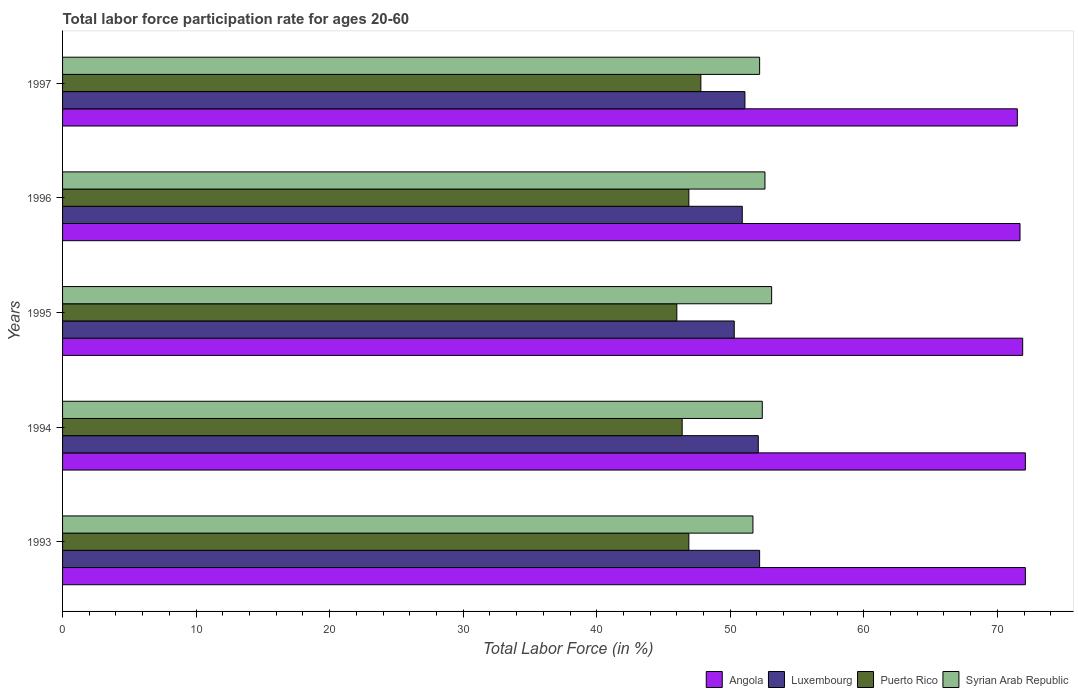How many different coloured bars are there?
Your answer should be very brief. 4. Are the number of bars per tick equal to the number of legend labels?
Provide a succinct answer. Yes. Are the number of bars on each tick of the Y-axis equal?
Offer a very short reply. Yes. How many bars are there on the 1st tick from the top?
Offer a terse response. 4. In how many cases, is the number of bars for a given year not equal to the number of legend labels?
Ensure brevity in your answer.  0. What is the labor force participation rate in Syrian Arab Republic in 1993?
Provide a short and direct response. 51.7. Across all years, what is the maximum labor force participation rate in Syrian Arab Republic?
Your answer should be very brief. 53.1. Across all years, what is the minimum labor force participation rate in Luxembourg?
Offer a very short reply. 50.3. In which year was the labor force participation rate in Angola maximum?
Provide a short and direct response. 1993. What is the total labor force participation rate in Syrian Arab Republic in the graph?
Offer a terse response. 262. What is the difference between the labor force participation rate in Puerto Rico in 1993 and that in 1994?
Offer a terse response. 0.5. What is the difference between the labor force participation rate in Luxembourg in 1993 and the labor force participation rate in Angola in 1995?
Offer a very short reply. -19.7. What is the average labor force participation rate in Puerto Rico per year?
Offer a terse response. 46.8. In the year 1996, what is the difference between the labor force participation rate in Angola and labor force participation rate in Syrian Arab Republic?
Make the answer very short. 19.1. What is the ratio of the labor force participation rate in Syrian Arab Republic in 1994 to that in 1996?
Offer a terse response. 1. What is the difference between the highest and the second highest labor force participation rate in Syrian Arab Republic?
Give a very brief answer. 0.5. What is the difference between the highest and the lowest labor force participation rate in Puerto Rico?
Provide a succinct answer. 1.8. What does the 2nd bar from the top in 1996 represents?
Ensure brevity in your answer.  Puerto Rico. What does the 3rd bar from the bottom in 1994 represents?
Give a very brief answer. Puerto Rico. How many bars are there?
Your response must be concise. 20. Are all the bars in the graph horizontal?
Give a very brief answer. Yes. Are the values on the major ticks of X-axis written in scientific E-notation?
Provide a short and direct response. No. How many legend labels are there?
Ensure brevity in your answer.  4. How are the legend labels stacked?
Ensure brevity in your answer.  Horizontal. What is the title of the graph?
Your response must be concise. Total labor force participation rate for ages 20-60. What is the Total Labor Force (in %) of Angola in 1993?
Provide a short and direct response. 72.1. What is the Total Labor Force (in %) of Luxembourg in 1993?
Your answer should be compact. 52.2. What is the Total Labor Force (in %) of Puerto Rico in 1993?
Offer a terse response. 46.9. What is the Total Labor Force (in %) of Syrian Arab Republic in 1993?
Ensure brevity in your answer.  51.7. What is the Total Labor Force (in %) of Angola in 1994?
Provide a succinct answer. 72.1. What is the Total Labor Force (in %) in Luxembourg in 1994?
Your answer should be compact. 52.1. What is the Total Labor Force (in %) of Puerto Rico in 1994?
Provide a short and direct response. 46.4. What is the Total Labor Force (in %) in Syrian Arab Republic in 1994?
Provide a succinct answer. 52.4. What is the Total Labor Force (in %) of Angola in 1995?
Provide a short and direct response. 71.9. What is the Total Labor Force (in %) in Luxembourg in 1995?
Give a very brief answer. 50.3. What is the Total Labor Force (in %) of Syrian Arab Republic in 1995?
Your response must be concise. 53.1. What is the Total Labor Force (in %) of Angola in 1996?
Give a very brief answer. 71.7. What is the Total Labor Force (in %) of Luxembourg in 1996?
Make the answer very short. 50.9. What is the Total Labor Force (in %) in Puerto Rico in 1996?
Offer a terse response. 46.9. What is the Total Labor Force (in %) of Syrian Arab Republic in 1996?
Your answer should be compact. 52.6. What is the Total Labor Force (in %) of Angola in 1997?
Offer a terse response. 71.5. What is the Total Labor Force (in %) in Luxembourg in 1997?
Offer a terse response. 51.1. What is the Total Labor Force (in %) in Puerto Rico in 1997?
Give a very brief answer. 47.8. What is the Total Labor Force (in %) in Syrian Arab Republic in 1997?
Keep it short and to the point. 52.2. Across all years, what is the maximum Total Labor Force (in %) in Angola?
Make the answer very short. 72.1. Across all years, what is the maximum Total Labor Force (in %) of Luxembourg?
Provide a short and direct response. 52.2. Across all years, what is the maximum Total Labor Force (in %) of Puerto Rico?
Give a very brief answer. 47.8. Across all years, what is the maximum Total Labor Force (in %) of Syrian Arab Republic?
Ensure brevity in your answer.  53.1. Across all years, what is the minimum Total Labor Force (in %) of Angola?
Ensure brevity in your answer.  71.5. Across all years, what is the minimum Total Labor Force (in %) of Luxembourg?
Provide a short and direct response. 50.3. Across all years, what is the minimum Total Labor Force (in %) of Puerto Rico?
Make the answer very short. 46. Across all years, what is the minimum Total Labor Force (in %) in Syrian Arab Republic?
Keep it short and to the point. 51.7. What is the total Total Labor Force (in %) in Angola in the graph?
Give a very brief answer. 359.3. What is the total Total Labor Force (in %) in Luxembourg in the graph?
Provide a short and direct response. 256.6. What is the total Total Labor Force (in %) of Puerto Rico in the graph?
Offer a terse response. 234. What is the total Total Labor Force (in %) in Syrian Arab Republic in the graph?
Keep it short and to the point. 262. What is the difference between the Total Labor Force (in %) in Angola in 1993 and that in 1994?
Make the answer very short. 0. What is the difference between the Total Labor Force (in %) in Luxembourg in 1993 and that in 1994?
Your response must be concise. 0.1. What is the difference between the Total Labor Force (in %) in Puerto Rico in 1993 and that in 1994?
Keep it short and to the point. 0.5. What is the difference between the Total Labor Force (in %) in Angola in 1993 and that in 1995?
Keep it short and to the point. 0.2. What is the difference between the Total Labor Force (in %) of Luxembourg in 1993 and that in 1995?
Your response must be concise. 1.9. What is the difference between the Total Labor Force (in %) of Syrian Arab Republic in 1993 and that in 1995?
Ensure brevity in your answer.  -1.4. What is the difference between the Total Labor Force (in %) of Angola in 1993 and that in 1997?
Provide a short and direct response. 0.6. What is the difference between the Total Labor Force (in %) of Syrian Arab Republic in 1993 and that in 1997?
Your response must be concise. -0.5. What is the difference between the Total Labor Force (in %) in Angola in 1994 and that in 1995?
Ensure brevity in your answer.  0.2. What is the difference between the Total Labor Force (in %) in Luxembourg in 1994 and that in 1995?
Provide a short and direct response. 1.8. What is the difference between the Total Labor Force (in %) in Puerto Rico in 1994 and that in 1995?
Offer a very short reply. 0.4. What is the difference between the Total Labor Force (in %) of Syrian Arab Republic in 1994 and that in 1995?
Offer a very short reply. -0.7. What is the difference between the Total Labor Force (in %) of Angola in 1994 and that in 1996?
Your answer should be very brief. 0.4. What is the difference between the Total Labor Force (in %) in Luxembourg in 1994 and that in 1996?
Make the answer very short. 1.2. What is the difference between the Total Labor Force (in %) in Syrian Arab Republic in 1994 and that in 1996?
Offer a very short reply. -0.2. What is the difference between the Total Labor Force (in %) in Syrian Arab Republic in 1994 and that in 1997?
Make the answer very short. 0.2. What is the difference between the Total Labor Force (in %) in Angola in 1995 and that in 1996?
Make the answer very short. 0.2. What is the difference between the Total Labor Force (in %) of Syrian Arab Republic in 1995 and that in 1996?
Your response must be concise. 0.5. What is the difference between the Total Labor Force (in %) in Luxembourg in 1995 and that in 1997?
Your answer should be very brief. -0.8. What is the difference between the Total Labor Force (in %) of Angola in 1996 and that in 1997?
Make the answer very short. 0.2. What is the difference between the Total Labor Force (in %) in Luxembourg in 1996 and that in 1997?
Make the answer very short. -0.2. What is the difference between the Total Labor Force (in %) of Puerto Rico in 1996 and that in 1997?
Your answer should be very brief. -0.9. What is the difference between the Total Labor Force (in %) of Syrian Arab Republic in 1996 and that in 1997?
Ensure brevity in your answer.  0.4. What is the difference between the Total Labor Force (in %) in Angola in 1993 and the Total Labor Force (in %) in Luxembourg in 1994?
Provide a succinct answer. 20. What is the difference between the Total Labor Force (in %) in Angola in 1993 and the Total Labor Force (in %) in Puerto Rico in 1994?
Provide a short and direct response. 25.7. What is the difference between the Total Labor Force (in %) in Angola in 1993 and the Total Labor Force (in %) in Syrian Arab Republic in 1994?
Your response must be concise. 19.7. What is the difference between the Total Labor Force (in %) of Luxembourg in 1993 and the Total Labor Force (in %) of Syrian Arab Republic in 1994?
Keep it short and to the point. -0.2. What is the difference between the Total Labor Force (in %) of Angola in 1993 and the Total Labor Force (in %) of Luxembourg in 1995?
Keep it short and to the point. 21.8. What is the difference between the Total Labor Force (in %) in Angola in 1993 and the Total Labor Force (in %) in Puerto Rico in 1995?
Offer a terse response. 26.1. What is the difference between the Total Labor Force (in %) of Luxembourg in 1993 and the Total Labor Force (in %) of Syrian Arab Republic in 1995?
Your answer should be compact. -0.9. What is the difference between the Total Labor Force (in %) in Angola in 1993 and the Total Labor Force (in %) in Luxembourg in 1996?
Your response must be concise. 21.2. What is the difference between the Total Labor Force (in %) of Angola in 1993 and the Total Labor Force (in %) of Puerto Rico in 1996?
Make the answer very short. 25.2. What is the difference between the Total Labor Force (in %) of Puerto Rico in 1993 and the Total Labor Force (in %) of Syrian Arab Republic in 1996?
Offer a terse response. -5.7. What is the difference between the Total Labor Force (in %) in Angola in 1993 and the Total Labor Force (in %) in Luxembourg in 1997?
Offer a very short reply. 21. What is the difference between the Total Labor Force (in %) of Angola in 1993 and the Total Labor Force (in %) of Puerto Rico in 1997?
Ensure brevity in your answer.  24.3. What is the difference between the Total Labor Force (in %) in Angola in 1994 and the Total Labor Force (in %) in Luxembourg in 1995?
Provide a short and direct response. 21.8. What is the difference between the Total Labor Force (in %) in Angola in 1994 and the Total Labor Force (in %) in Puerto Rico in 1995?
Your answer should be compact. 26.1. What is the difference between the Total Labor Force (in %) of Luxembourg in 1994 and the Total Labor Force (in %) of Syrian Arab Republic in 1995?
Your answer should be very brief. -1. What is the difference between the Total Labor Force (in %) of Angola in 1994 and the Total Labor Force (in %) of Luxembourg in 1996?
Give a very brief answer. 21.2. What is the difference between the Total Labor Force (in %) of Angola in 1994 and the Total Labor Force (in %) of Puerto Rico in 1996?
Provide a succinct answer. 25.2. What is the difference between the Total Labor Force (in %) in Angola in 1994 and the Total Labor Force (in %) in Syrian Arab Republic in 1996?
Your response must be concise. 19.5. What is the difference between the Total Labor Force (in %) in Luxembourg in 1994 and the Total Labor Force (in %) in Puerto Rico in 1996?
Provide a short and direct response. 5.2. What is the difference between the Total Labor Force (in %) of Luxembourg in 1994 and the Total Labor Force (in %) of Syrian Arab Republic in 1996?
Offer a very short reply. -0.5. What is the difference between the Total Labor Force (in %) in Puerto Rico in 1994 and the Total Labor Force (in %) in Syrian Arab Republic in 1996?
Your answer should be compact. -6.2. What is the difference between the Total Labor Force (in %) in Angola in 1994 and the Total Labor Force (in %) in Puerto Rico in 1997?
Keep it short and to the point. 24.3. What is the difference between the Total Labor Force (in %) of Luxembourg in 1994 and the Total Labor Force (in %) of Puerto Rico in 1997?
Your answer should be very brief. 4.3. What is the difference between the Total Labor Force (in %) in Puerto Rico in 1994 and the Total Labor Force (in %) in Syrian Arab Republic in 1997?
Ensure brevity in your answer.  -5.8. What is the difference between the Total Labor Force (in %) of Angola in 1995 and the Total Labor Force (in %) of Syrian Arab Republic in 1996?
Keep it short and to the point. 19.3. What is the difference between the Total Labor Force (in %) of Luxembourg in 1995 and the Total Labor Force (in %) of Syrian Arab Republic in 1996?
Ensure brevity in your answer.  -2.3. What is the difference between the Total Labor Force (in %) of Puerto Rico in 1995 and the Total Labor Force (in %) of Syrian Arab Republic in 1996?
Your response must be concise. -6.6. What is the difference between the Total Labor Force (in %) of Angola in 1995 and the Total Labor Force (in %) of Luxembourg in 1997?
Provide a succinct answer. 20.8. What is the difference between the Total Labor Force (in %) in Angola in 1995 and the Total Labor Force (in %) in Puerto Rico in 1997?
Your answer should be compact. 24.1. What is the difference between the Total Labor Force (in %) in Luxembourg in 1995 and the Total Labor Force (in %) in Puerto Rico in 1997?
Give a very brief answer. 2.5. What is the difference between the Total Labor Force (in %) of Angola in 1996 and the Total Labor Force (in %) of Luxembourg in 1997?
Provide a succinct answer. 20.6. What is the difference between the Total Labor Force (in %) of Angola in 1996 and the Total Labor Force (in %) of Puerto Rico in 1997?
Your answer should be very brief. 23.9. What is the difference between the Total Labor Force (in %) in Angola in 1996 and the Total Labor Force (in %) in Syrian Arab Republic in 1997?
Your answer should be compact. 19.5. What is the difference between the Total Labor Force (in %) of Luxembourg in 1996 and the Total Labor Force (in %) of Puerto Rico in 1997?
Ensure brevity in your answer.  3.1. What is the difference between the Total Labor Force (in %) of Puerto Rico in 1996 and the Total Labor Force (in %) of Syrian Arab Republic in 1997?
Your answer should be very brief. -5.3. What is the average Total Labor Force (in %) in Angola per year?
Keep it short and to the point. 71.86. What is the average Total Labor Force (in %) in Luxembourg per year?
Provide a short and direct response. 51.32. What is the average Total Labor Force (in %) of Puerto Rico per year?
Ensure brevity in your answer.  46.8. What is the average Total Labor Force (in %) in Syrian Arab Republic per year?
Provide a short and direct response. 52.4. In the year 1993, what is the difference between the Total Labor Force (in %) of Angola and Total Labor Force (in %) of Puerto Rico?
Ensure brevity in your answer.  25.2. In the year 1993, what is the difference between the Total Labor Force (in %) of Angola and Total Labor Force (in %) of Syrian Arab Republic?
Provide a succinct answer. 20.4. In the year 1994, what is the difference between the Total Labor Force (in %) in Angola and Total Labor Force (in %) in Luxembourg?
Make the answer very short. 20. In the year 1994, what is the difference between the Total Labor Force (in %) of Angola and Total Labor Force (in %) of Puerto Rico?
Keep it short and to the point. 25.7. In the year 1994, what is the difference between the Total Labor Force (in %) of Angola and Total Labor Force (in %) of Syrian Arab Republic?
Make the answer very short. 19.7. In the year 1994, what is the difference between the Total Labor Force (in %) in Luxembourg and Total Labor Force (in %) in Syrian Arab Republic?
Make the answer very short. -0.3. In the year 1995, what is the difference between the Total Labor Force (in %) in Angola and Total Labor Force (in %) in Luxembourg?
Offer a terse response. 21.6. In the year 1995, what is the difference between the Total Labor Force (in %) of Angola and Total Labor Force (in %) of Puerto Rico?
Keep it short and to the point. 25.9. In the year 1996, what is the difference between the Total Labor Force (in %) in Angola and Total Labor Force (in %) in Luxembourg?
Provide a short and direct response. 20.8. In the year 1996, what is the difference between the Total Labor Force (in %) of Angola and Total Labor Force (in %) of Puerto Rico?
Offer a very short reply. 24.8. In the year 1996, what is the difference between the Total Labor Force (in %) of Angola and Total Labor Force (in %) of Syrian Arab Republic?
Offer a terse response. 19.1. In the year 1996, what is the difference between the Total Labor Force (in %) in Luxembourg and Total Labor Force (in %) in Puerto Rico?
Your answer should be compact. 4. In the year 1996, what is the difference between the Total Labor Force (in %) of Luxembourg and Total Labor Force (in %) of Syrian Arab Republic?
Your response must be concise. -1.7. In the year 1996, what is the difference between the Total Labor Force (in %) in Puerto Rico and Total Labor Force (in %) in Syrian Arab Republic?
Provide a short and direct response. -5.7. In the year 1997, what is the difference between the Total Labor Force (in %) of Angola and Total Labor Force (in %) of Luxembourg?
Provide a succinct answer. 20.4. In the year 1997, what is the difference between the Total Labor Force (in %) of Angola and Total Labor Force (in %) of Puerto Rico?
Provide a short and direct response. 23.7. In the year 1997, what is the difference between the Total Labor Force (in %) in Angola and Total Labor Force (in %) in Syrian Arab Republic?
Make the answer very short. 19.3. What is the ratio of the Total Labor Force (in %) in Angola in 1993 to that in 1994?
Keep it short and to the point. 1. What is the ratio of the Total Labor Force (in %) in Puerto Rico in 1993 to that in 1994?
Your answer should be compact. 1.01. What is the ratio of the Total Labor Force (in %) in Syrian Arab Republic in 1993 to that in 1994?
Your answer should be very brief. 0.99. What is the ratio of the Total Labor Force (in %) of Luxembourg in 1993 to that in 1995?
Your response must be concise. 1.04. What is the ratio of the Total Labor Force (in %) of Puerto Rico in 1993 to that in 1995?
Your response must be concise. 1.02. What is the ratio of the Total Labor Force (in %) of Syrian Arab Republic in 1993 to that in 1995?
Your answer should be compact. 0.97. What is the ratio of the Total Labor Force (in %) of Angola in 1993 to that in 1996?
Ensure brevity in your answer.  1.01. What is the ratio of the Total Labor Force (in %) of Luxembourg in 1993 to that in 1996?
Ensure brevity in your answer.  1.03. What is the ratio of the Total Labor Force (in %) in Puerto Rico in 1993 to that in 1996?
Keep it short and to the point. 1. What is the ratio of the Total Labor Force (in %) of Syrian Arab Republic in 1993 to that in 1996?
Your answer should be very brief. 0.98. What is the ratio of the Total Labor Force (in %) in Angola in 1993 to that in 1997?
Keep it short and to the point. 1.01. What is the ratio of the Total Labor Force (in %) in Luxembourg in 1993 to that in 1997?
Provide a succinct answer. 1.02. What is the ratio of the Total Labor Force (in %) in Puerto Rico in 1993 to that in 1997?
Provide a short and direct response. 0.98. What is the ratio of the Total Labor Force (in %) in Syrian Arab Republic in 1993 to that in 1997?
Offer a very short reply. 0.99. What is the ratio of the Total Labor Force (in %) of Luxembourg in 1994 to that in 1995?
Provide a succinct answer. 1.04. What is the ratio of the Total Labor Force (in %) in Puerto Rico in 1994 to that in 1995?
Provide a succinct answer. 1.01. What is the ratio of the Total Labor Force (in %) of Angola in 1994 to that in 1996?
Your response must be concise. 1.01. What is the ratio of the Total Labor Force (in %) in Luxembourg in 1994 to that in 1996?
Give a very brief answer. 1.02. What is the ratio of the Total Labor Force (in %) of Puerto Rico in 1994 to that in 1996?
Give a very brief answer. 0.99. What is the ratio of the Total Labor Force (in %) of Syrian Arab Republic in 1994 to that in 1996?
Your answer should be very brief. 1. What is the ratio of the Total Labor Force (in %) in Angola in 1994 to that in 1997?
Your answer should be very brief. 1.01. What is the ratio of the Total Labor Force (in %) in Luxembourg in 1994 to that in 1997?
Your answer should be very brief. 1.02. What is the ratio of the Total Labor Force (in %) in Puerto Rico in 1994 to that in 1997?
Give a very brief answer. 0.97. What is the ratio of the Total Labor Force (in %) in Syrian Arab Republic in 1994 to that in 1997?
Give a very brief answer. 1. What is the ratio of the Total Labor Force (in %) in Angola in 1995 to that in 1996?
Provide a succinct answer. 1. What is the ratio of the Total Labor Force (in %) of Puerto Rico in 1995 to that in 1996?
Give a very brief answer. 0.98. What is the ratio of the Total Labor Force (in %) of Syrian Arab Republic in 1995 to that in 1996?
Give a very brief answer. 1.01. What is the ratio of the Total Labor Force (in %) of Angola in 1995 to that in 1997?
Provide a succinct answer. 1.01. What is the ratio of the Total Labor Force (in %) in Luxembourg in 1995 to that in 1997?
Give a very brief answer. 0.98. What is the ratio of the Total Labor Force (in %) of Puerto Rico in 1995 to that in 1997?
Make the answer very short. 0.96. What is the ratio of the Total Labor Force (in %) of Syrian Arab Republic in 1995 to that in 1997?
Your response must be concise. 1.02. What is the ratio of the Total Labor Force (in %) in Angola in 1996 to that in 1997?
Offer a very short reply. 1. What is the ratio of the Total Labor Force (in %) in Puerto Rico in 1996 to that in 1997?
Your answer should be very brief. 0.98. What is the ratio of the Total Labor Force (in %) of Syrian Arab Republic in 1996 to that in 1997?
Offer a terse response. 1.01. What is the difference between the highest and the second highest Total Labor Force (in %) in Angola?
Offer a very short reply. 0. What is the difference between the highest and the second highest Total Labor Force (in %) in Luxembourg?
Ensure brevity in your answer.  0.1. What is the difference between the highest and the second highest Total Labor Force (in %) of Syrian Arab Republic?
Your response must be concise. 0.5. 